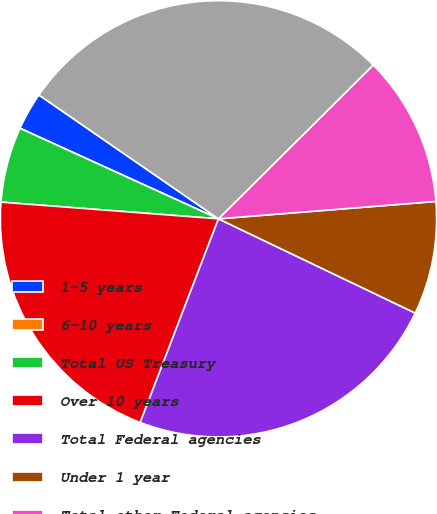<chart> <loc_0><loc_0><loc_500><loc_500><pie_chart><fcel>1-5 years<fcel>6-10 years<fcel>Total US Treasury<fcel>Over 10 years<fcel>Total Federal agencies<fcel>Under 1 year<fcel>Total other Federal agencies<fcel>Total US Government backed<nl><fcel>2.8%<fcel>0.0%<fcel>5.59%<fcel>20.38%<fcel>23.73%<fcel>8.38%<fcel>11.18%<fcel>27.94%<nl></chart> 